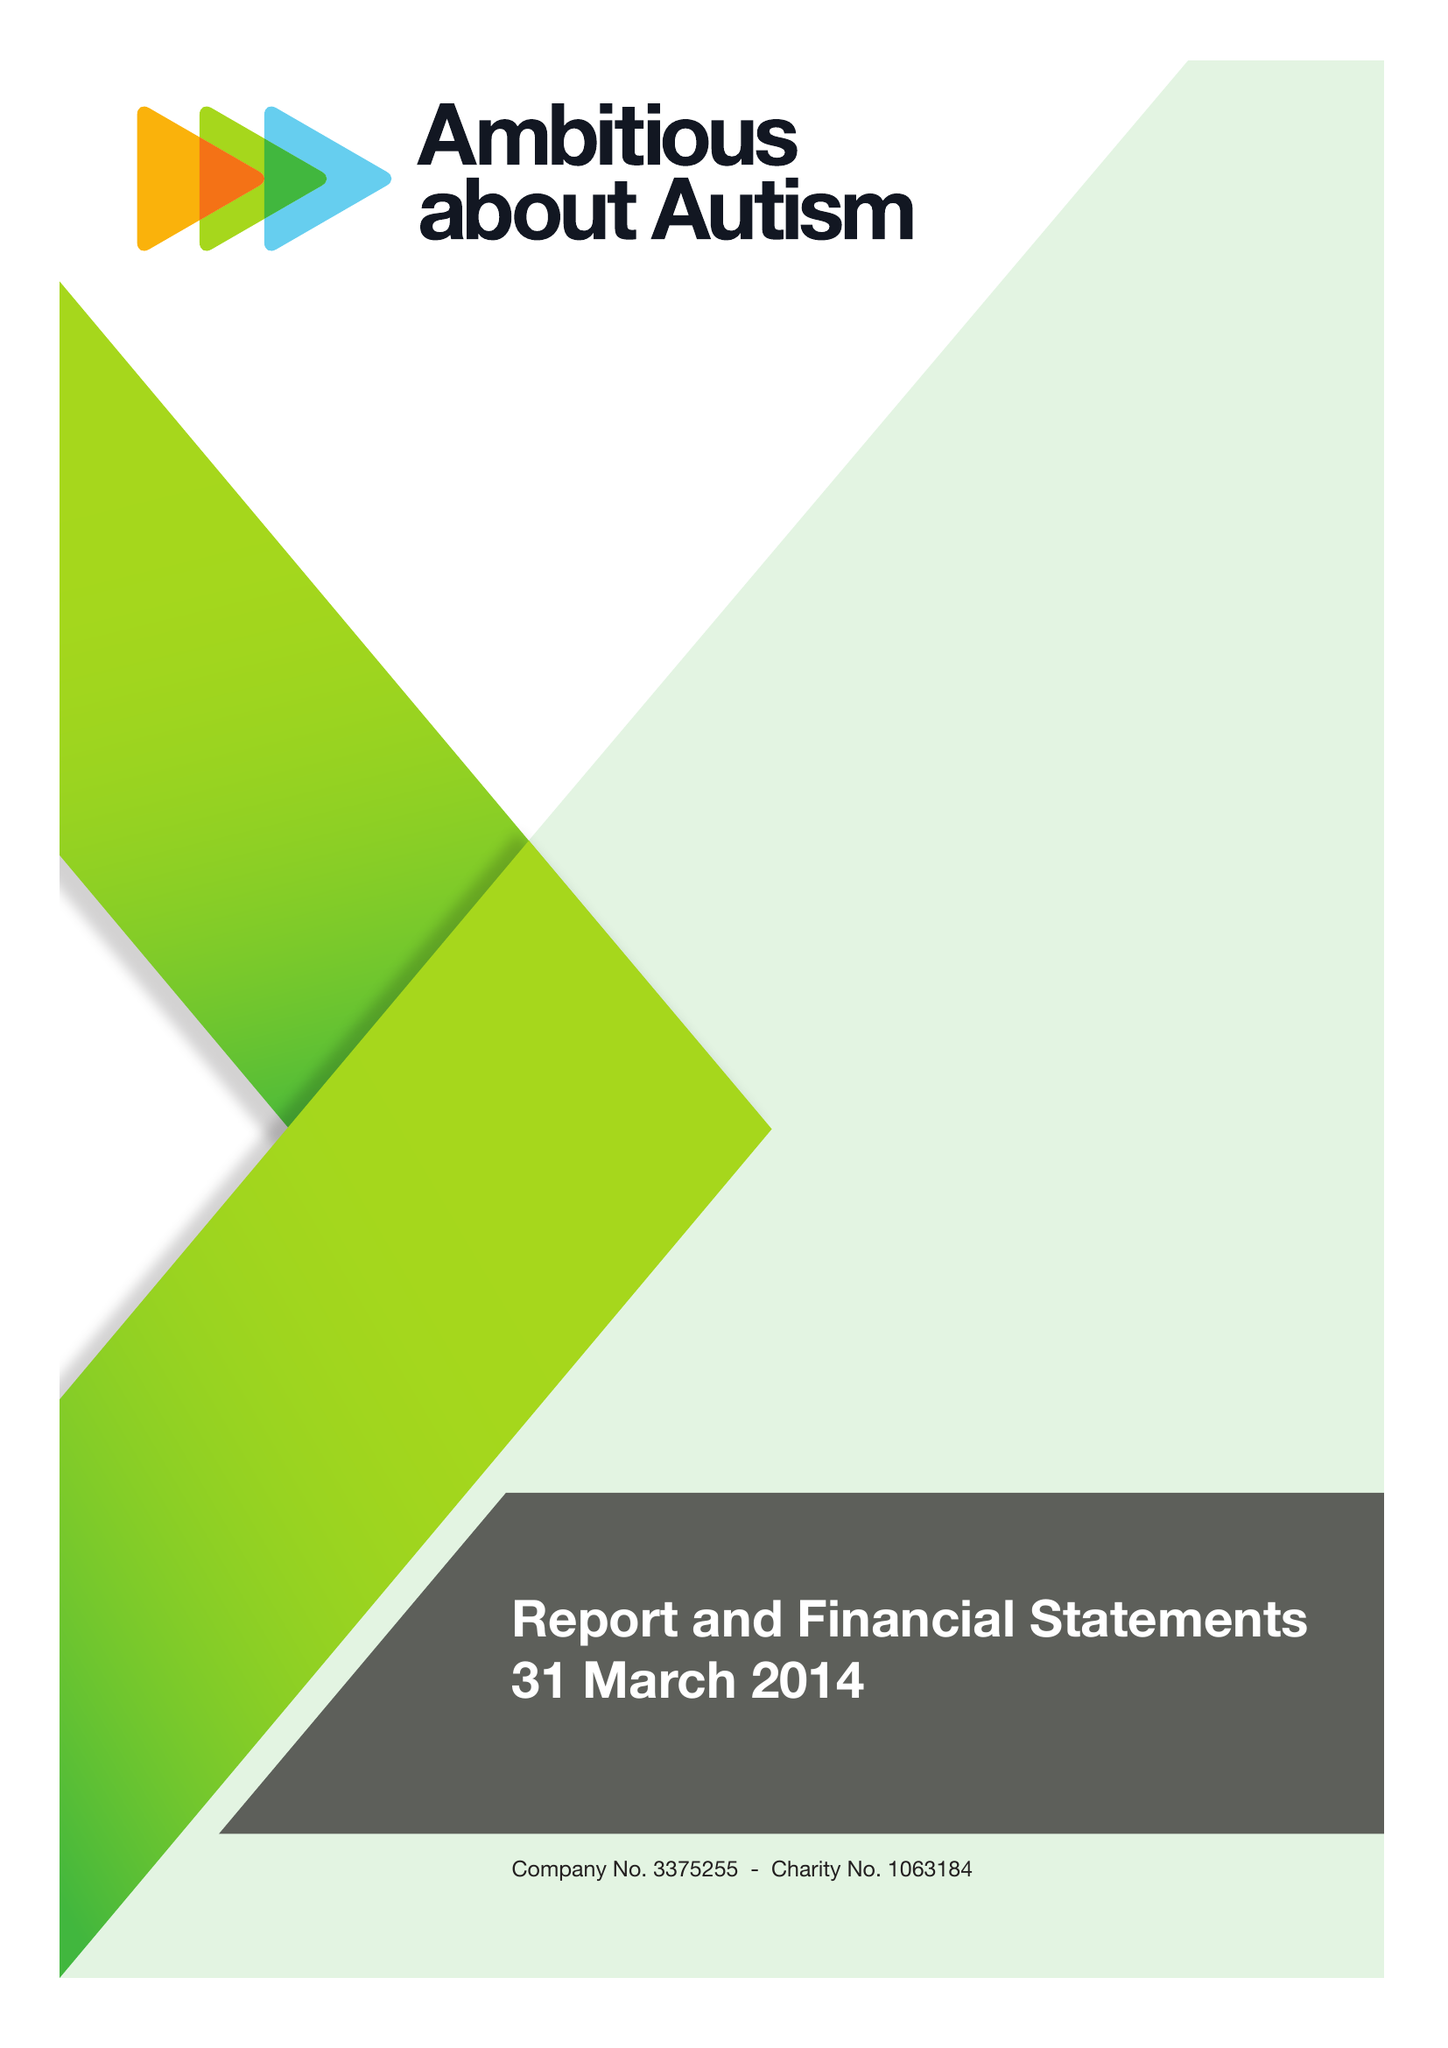What is the value for the address__post_town?
Answer the question using a single word or phrase. LONDON 